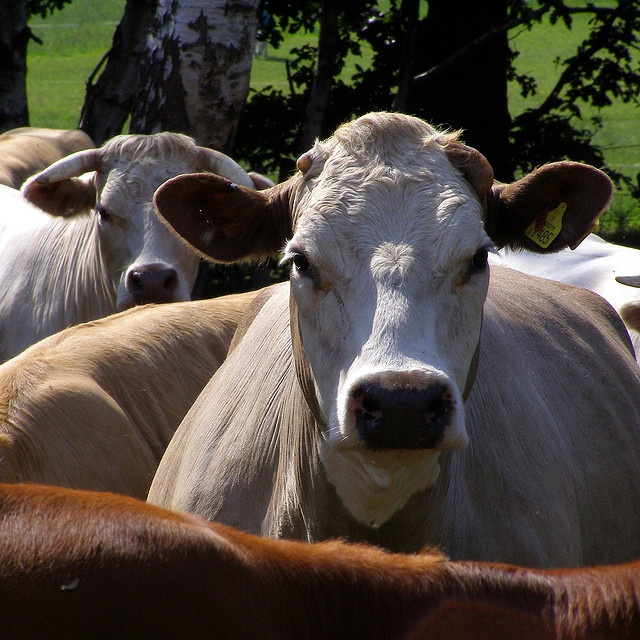Describe the objects in this image and their specific colors. I can see cow in black, gray, darkgray, and lightgray tones, cow in black, maroon, gray, and brown tones, cow in black and tan tones, cow in black, gray, white, and darkgray tones, and cow in black, white, and darkgray tones in this image. 